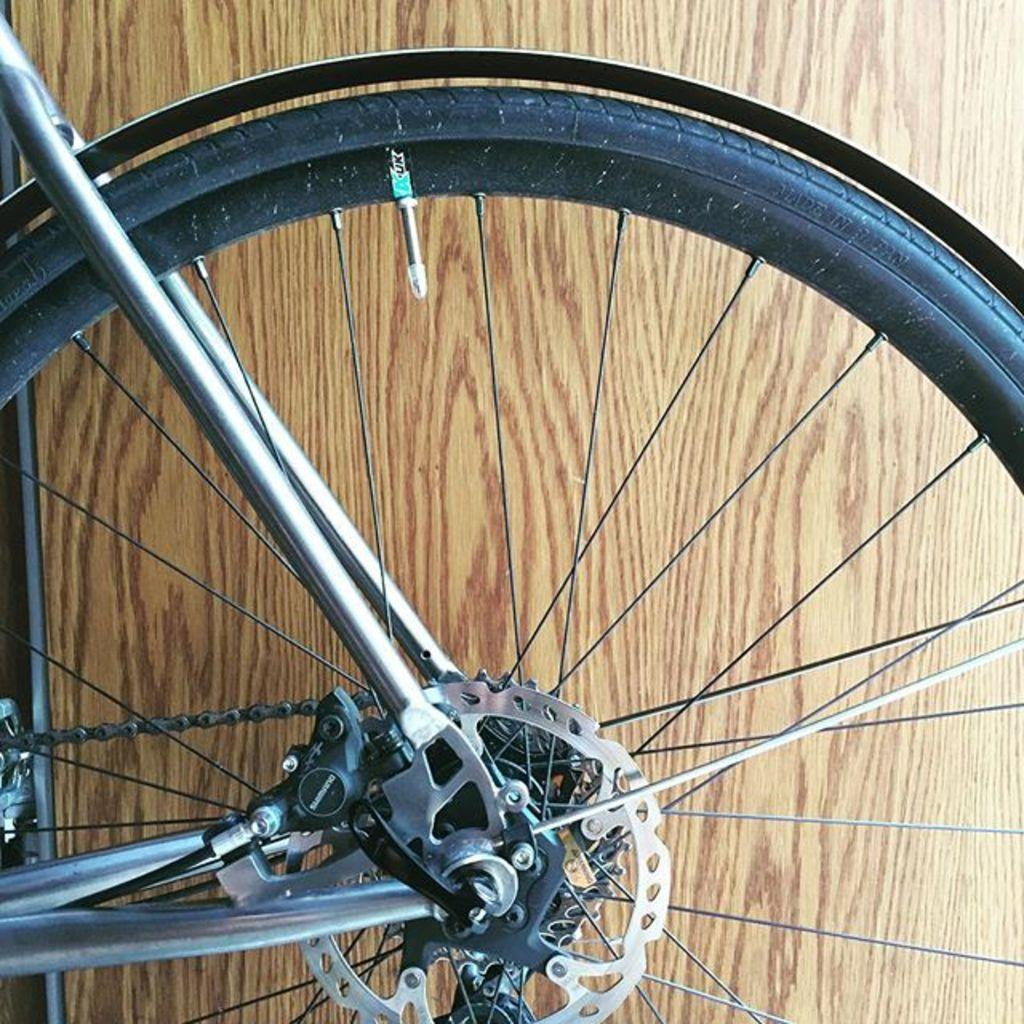What object is located at the bottom of the image? There is a wheel of a bicycle at the bottom of the image. What type of material is used for the wall in the background? The wall in the background is made of wood. What type of cannon is present in the image? There is no cannon present in the image. How many bees can be seen flying around the bicycle wheel in the image? There are no bees present in the image. 